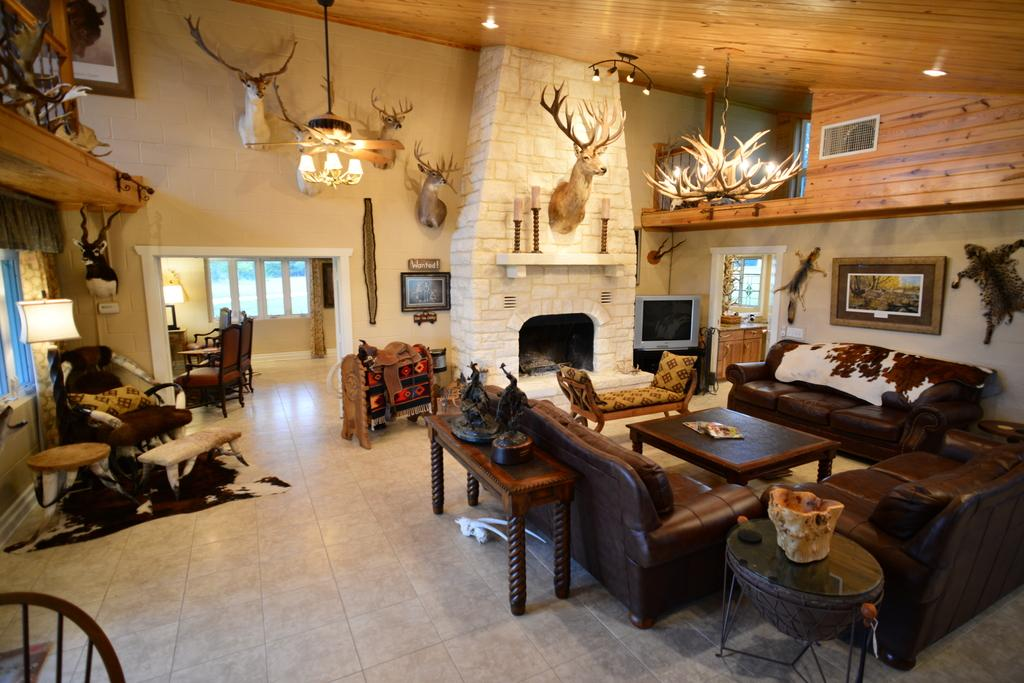What type of furniture is present in the image? There are sofas and chairs in the image. What is the primary piece of furniture in the image? There is a table in the image. What can be seen on the walls in the image? There are frames and decorations on the wall in the image. How does the disgust in the image affect the furniture? There is no indication of disgust in the image, and therefore it cannot affect the furniture. 